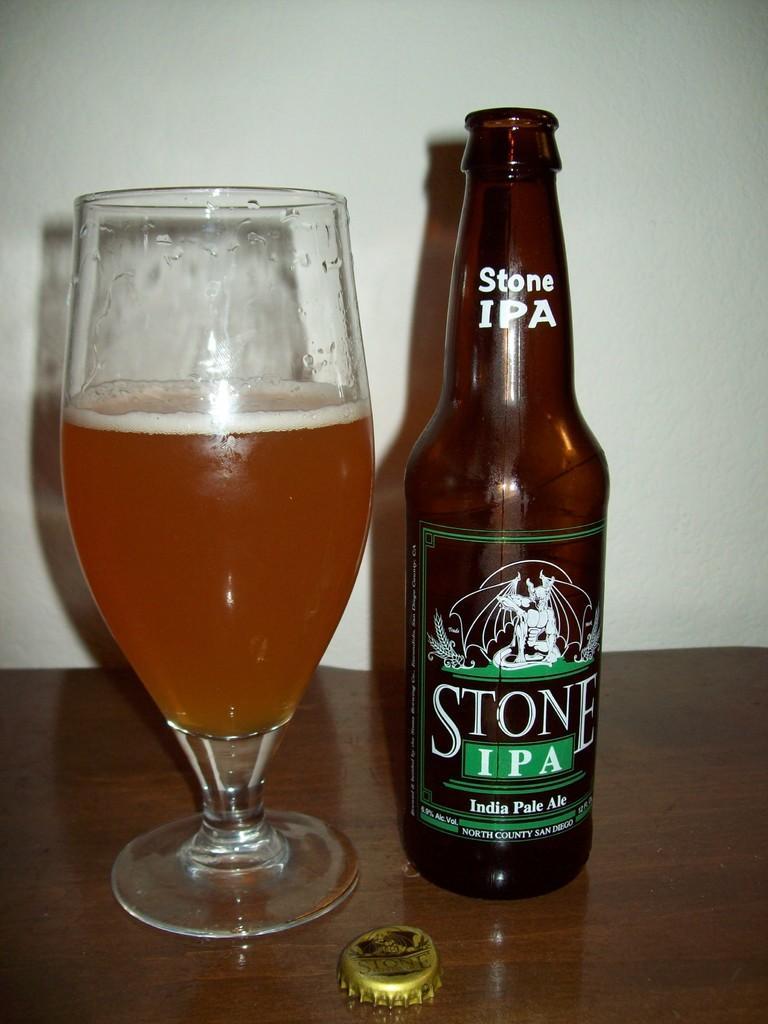In one or two sentences, can you explain what this image depicts? There is a table. The bottle and wine glass are on top of the table. We can see in background white color wall. 